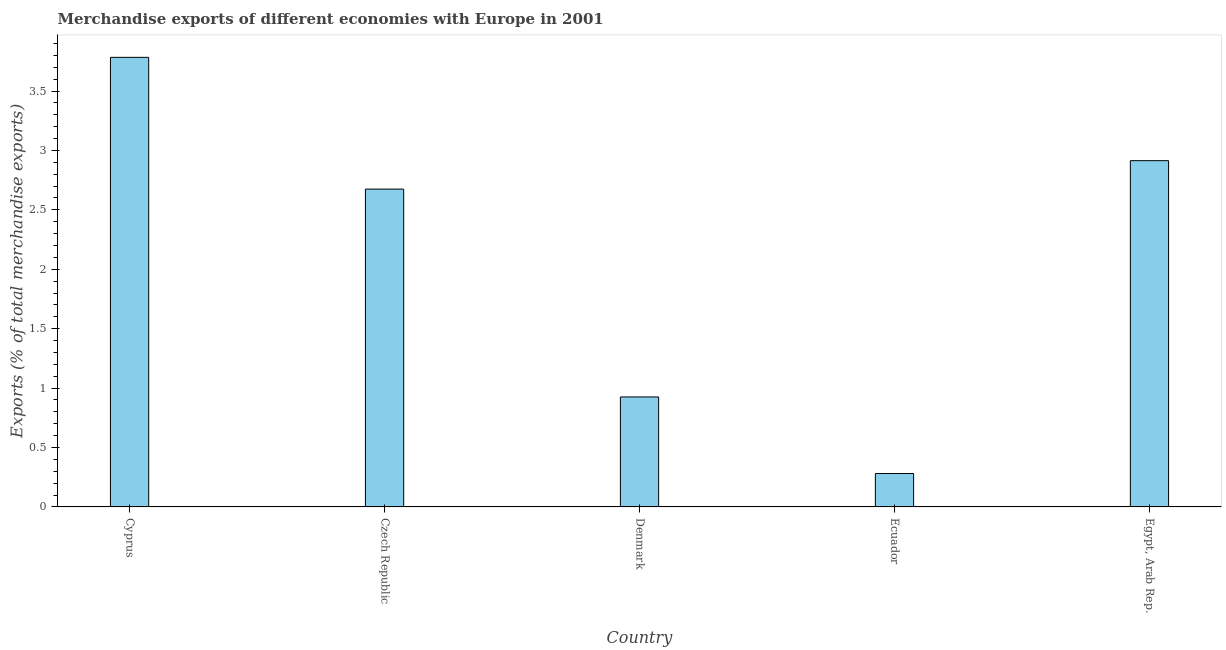Does the graph contain any zero values?
Offer a very short reply. No. What is the title of the graph?
Make the answer very short. Merchandise exports of different economies with Europe in 2001. What is the label or title of the Y-axis?
Your answer should be very brief. Exports (% of total merchandise exports). What is the merchandise exports in Egypt, Arab Rep.?
Make the answer very short. 2.91. Across all countries, what is the maximum merchandise exports?
Provide a succinct answer. 3.78. Across all countries, what is the minimum merchandise exports?
Provide a short and direct response. 0.28. In which country was the merchandise exports maximum?
Make the answer very short. Cyprus. In which country was the merchandise exports minimum?
Give a very brief answer. Ecuador. What is the sum of the merchandise exports?
Your response must be concise. 10.58. What is the difference between the merchandise exports in Cyprus and Czech Republic?
Your answer should be compact. 1.11. What is the average merchandise exports per country?
Your answer should be very brief. 2.12. What is the median merchandise exports?
Give a very brief answer. 2.67. What is the ratio of the merchandise exports in Cyprus to that in Ecuador?
Your answer should be compact. 13.45. Is the merchandise exports in Cyprus less than that in Czech Republic?
Offer a terse response. No. What is the difference between the highest and the second highest merchandise exports?
Your answer should be compact. 0.87. How many countries are there in the graph?
Ensure brevity in your answer.  5. What is the difference between two consecutive major ticks on the Y-axis?
Your answer should be compact. 0.5. Are the values on the major ticks of Y-axis written in scientific E-notation?
Offer a terse response. No. What is the Exports (% of total merchandise exports) of Cyprus?
Provide a succinct answer. 3.78. What is the Exports (% of total merchandise exports) in Czech Republic?
Keep it short and to the point. 2.67. What is the Exports (% of total merchandise exports) of Denmark?
Provide a short and direct response. 0.93. What is the Exports (% of total merchandise exports) in Ecuador?
Ensure brevity in your answer.  0.28. What is the Exports (% of total merchandise exports) of Egypt, Arab Rep.?
Give a very brief answer. 2.91. What is the difference between the Exports (% of total merchandise exports) in Cyprus and Czech Republic?
Give a very brief answer. 1.11. What is the difference between the Exports (% of total merchandise exports) in Cyprus and Denmark?
Your answer should be very brief. 2.86. What is the difference between the Exports (% of total merchandise exports) in Cyprus and Ecuador?
Your response must be concise. 3.5. What is the difference between the Exports (% of total merchandise exports) in Cyprus and Egypt, Arab Rep.?
Your response must be concise. 0.87. What is the difference between the Exports (% of total merchandise exports) in Czech Republic and Denmark?
Your answer should be compact. 1.75. What is the difference between the Exports (% of total merchandise exports) in Czech Republic and Ecuador?
Provide a succinct answer. 2.39. What is the difference between the Exports (% of total merchandise exports) in Czech Republic and Egypt, Arab Rep.?
Make the answer very short. -0.24. What is the difference between the Exports (% of total merchandise exports) in Denmark and Ecuador?
Keep it short and to the point. 0.64. What is the difference between the Exports (% of total merchandise exports) in Denmark and Egypt, Arab Rep.?
Your response must be concise. -1.99. What is the difference between the Exports (% of total merchandise exports) in Ecuador and Egypt, Arab Rep.?
Your response must be concise. -2.63. What is the ratio of the Exports (% of total merchandise exports) in Cyprus to that in Czech Republic?
Ensure brevity in your answer.  1.42. What is the ratio of the Exports (% of total merchandise exports) in Cyprus to that in Denmark?
Offer a terse response. 4.09. What is the ratio of the Exports (% of total merchandise exports) in Cyprus to that in Ecuador?
Give a very brief answer. 13.45. What is the ratio of the Exports (% of total merchandise exports) in Cyprus to that in Egypt, Arab Rep.?
Provide a succinct answer. 1.3. What is the ratio of the Exports (% of total merchandise exports) in Czech Republic to that in Denmark?
Your response must be concise. 2.89. What is the ratio of the Exports (% of total merchandise exports) in Czech Republic to that in Ecuador?
Provide a succinct answer. 9.51. What is the ratio of the Exports (% of total merchandise exports) in Czech Republic to that in Egypt, Arab Rep.?
Provide a succinct answer. 0.92. What is the ratio of the Exports (% of total merchandise exports) in Denmark to that in Ecuador?
Offer a very short reply. 3.29. What is the ratio of the Exports (% of total merchandise exports) in Denmark to that in Egypt, Arab Rep.?
Offer a very short reply. 0.32. What is the ratio of the Exports (% of total merchandise exports) in Ecuador to that in Egypt, Arab Rep.?
Offer a terse response. 0.1. 